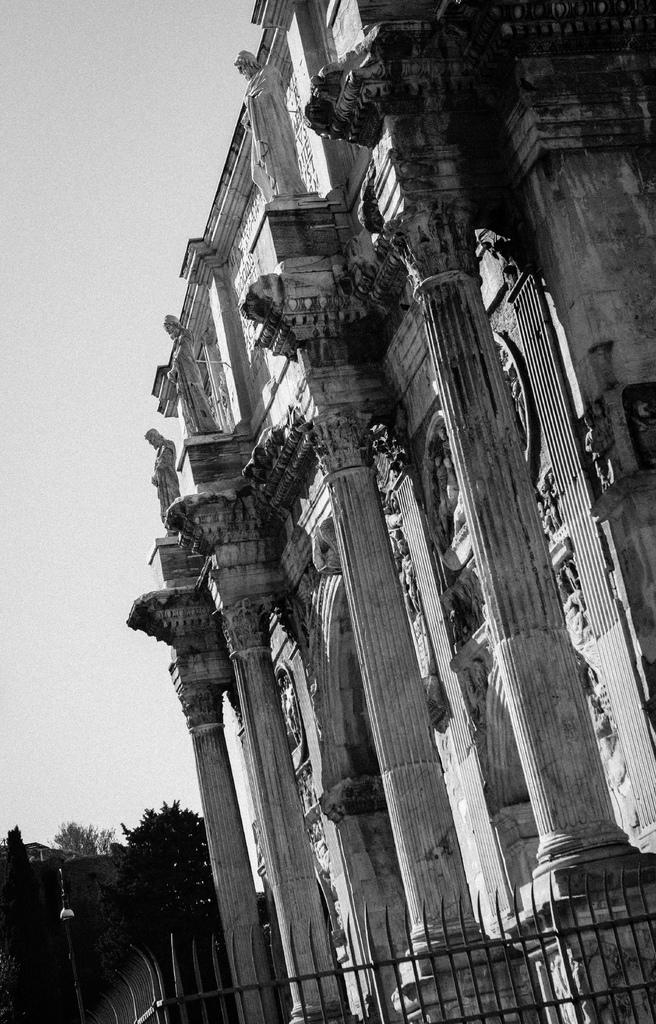What type of structure is visible in the image? There is a building in the image. What other objects can be seen in the image? There are poles, statues, fencing, and trees visible in the image. How many hearts can be seen in the image? There are no hearts visible in the image. 